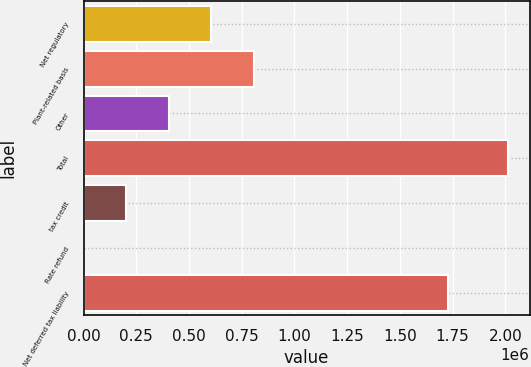Convert chart to OTSL. <chart><loc_0><loc_0><loc_500><loc_500><bar_chart><fcel>Net regulatory<fcel>Plant-related basis<fcel>Other<fcel>Total<fcel>tax credit<fcel>Rate refund<fcel>Net deferred tax liability<nl><fcel>604991<fcel>806955<fcel>403590<fcel>2.0148e+06<fcel>202190<fcel>789<fcel>1.72872e+06<nl></chart> 